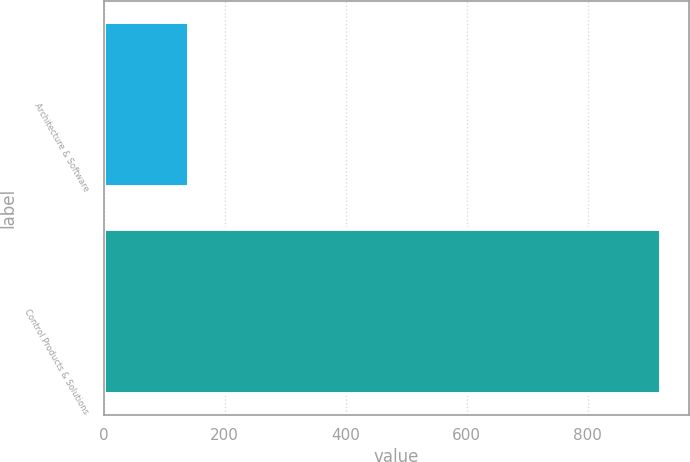<chart> <loc_0><loc_0><loc_500><loc_500><bar_chart><fcel>Architecture & Software<fcel>Control Products & Solutions<nl><fcel>140.6<fcel>921<nl></chart> 